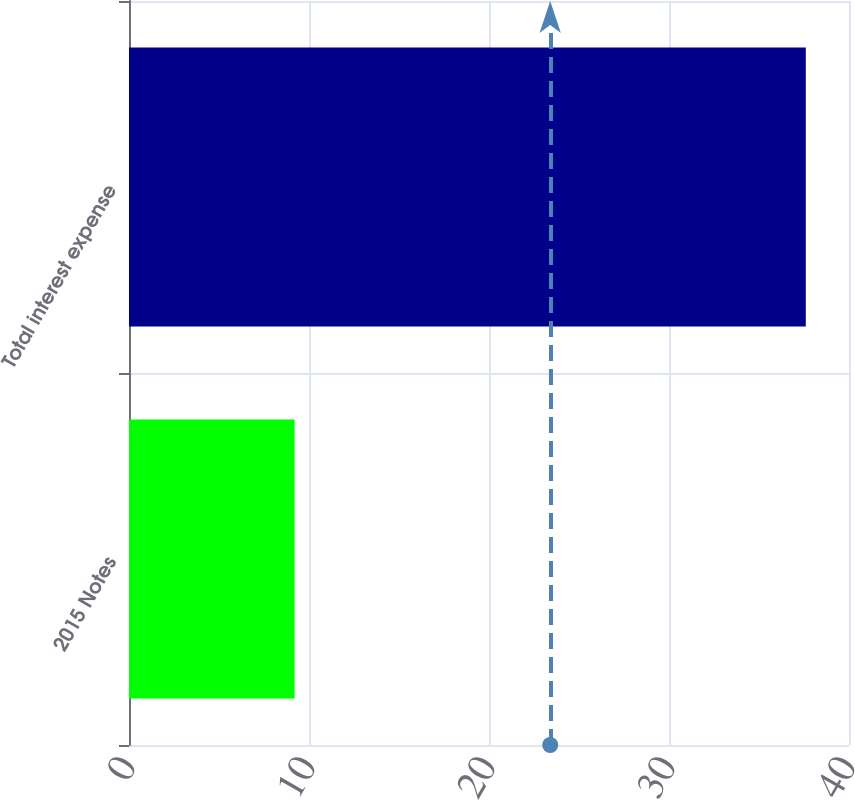Convert chart. <chart><loc_0><loc_0><loc_500><loc_500><bar_chart><fcel>2015 Notes<fcel>Total interest expense<nl><fcel>9.2<fcel>37.6<nl></chart> 